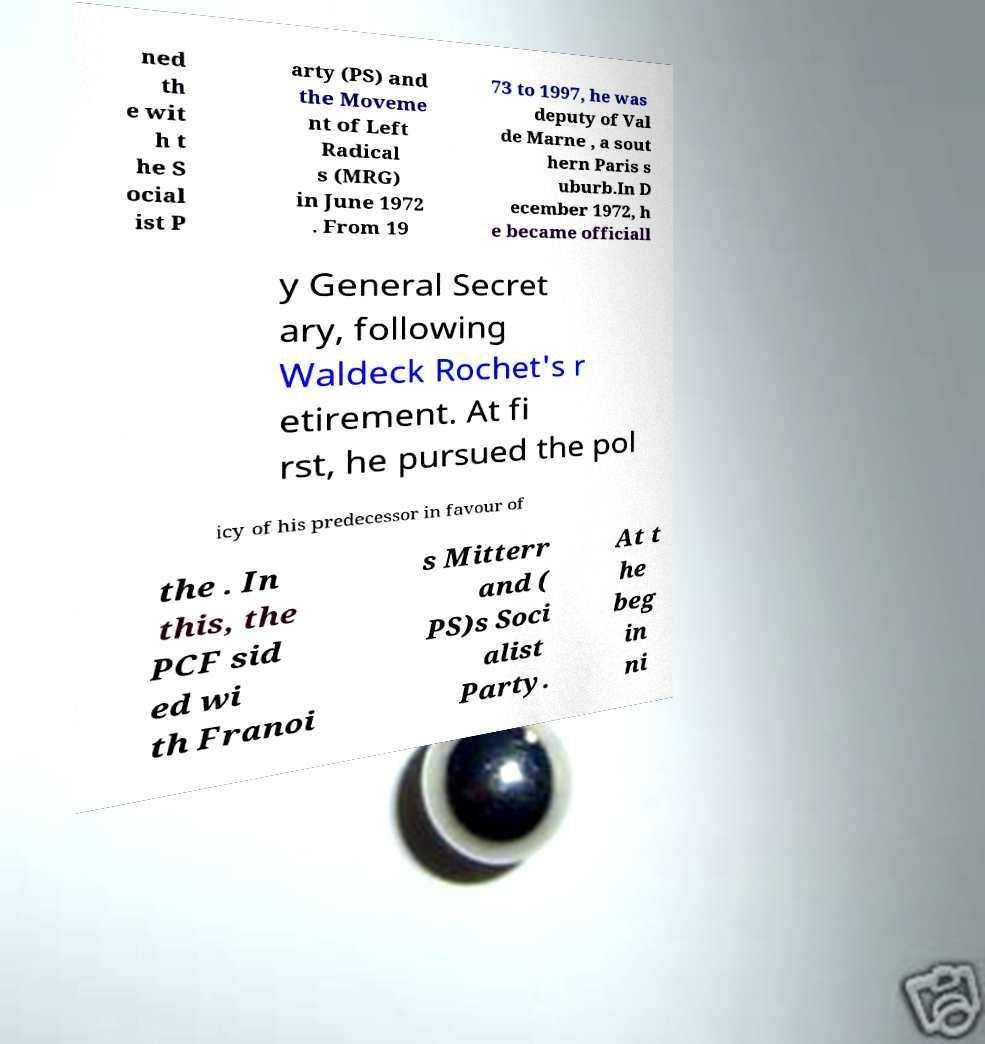Please identify and transcribe the text found in this image. ned th e wit h t he S ocial ist P arty (PS) and the Moveme nt of Left Radical s (MRG) in June 1972 . From 19 73 to 1997, he was deputy of Val de Marne , a sout hern Paris s uburb.In D ecember 1972, h e became officiall y General Secret ary, following Waldeck Rochet's r etirement. At fi rst, he pursued the pol icy of his predecessor in favour of the . In this, the PCF sid ed wi th Franoi s Mitterr and ( PS)s Soci alist Party. At t he beg in ni 